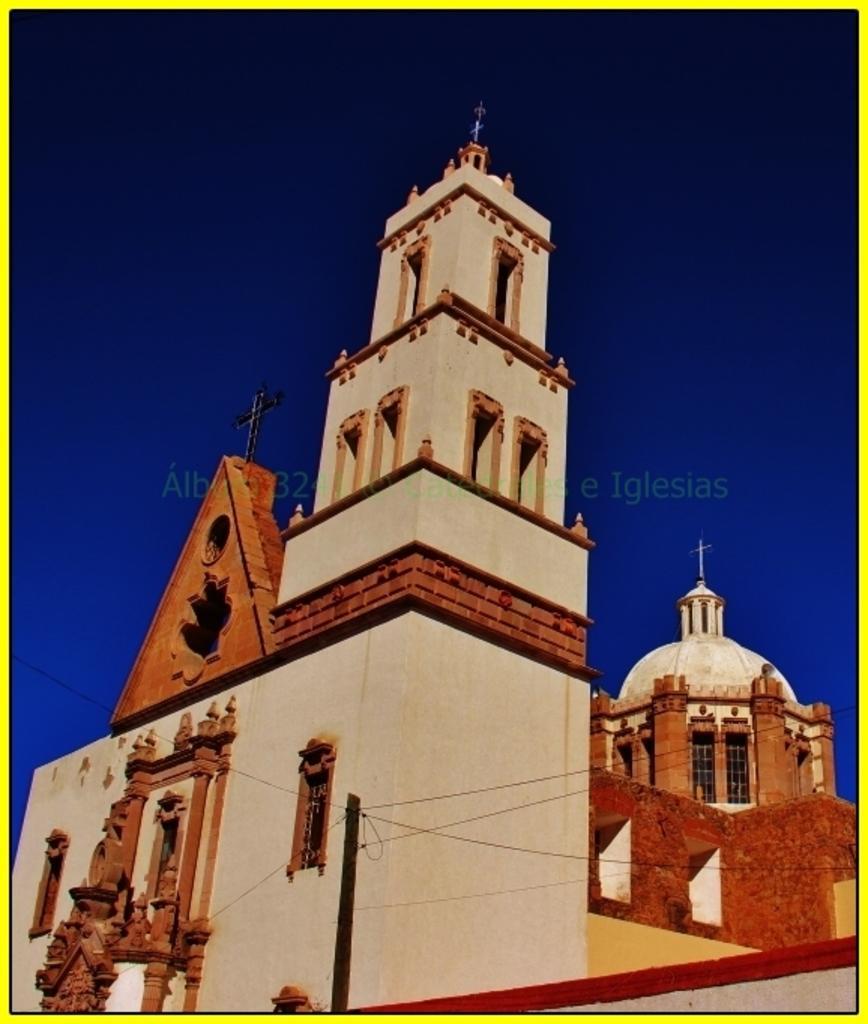Could you give a brief overview of what you see in this image? This is a church with windows and arches. On the church there are crosses. In the background there is sky. Also there is a watermark on the image. 